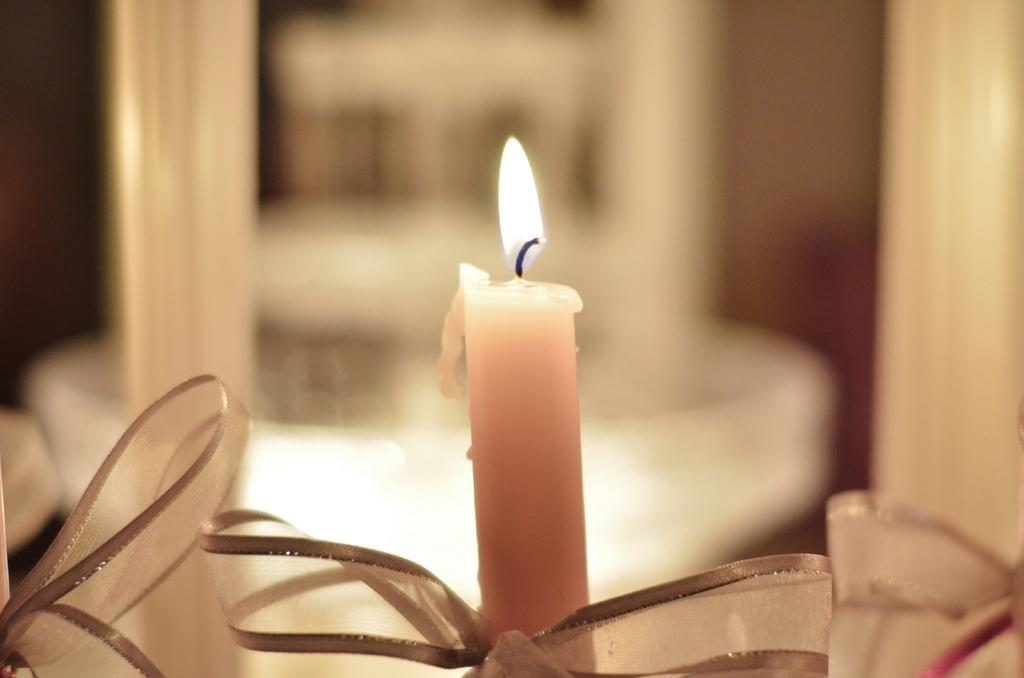What is the main object in the image? There is a candle in the image. What is the state of the candle? The candle is lightened. Are there any objects near the candle? Yes, there are objects beside the candle. What can be seen in the background of the image? There are other objects in the background of the image. What is the income of the fan in the image? There is no fan present in the image, so it is not possible to determine its income. 